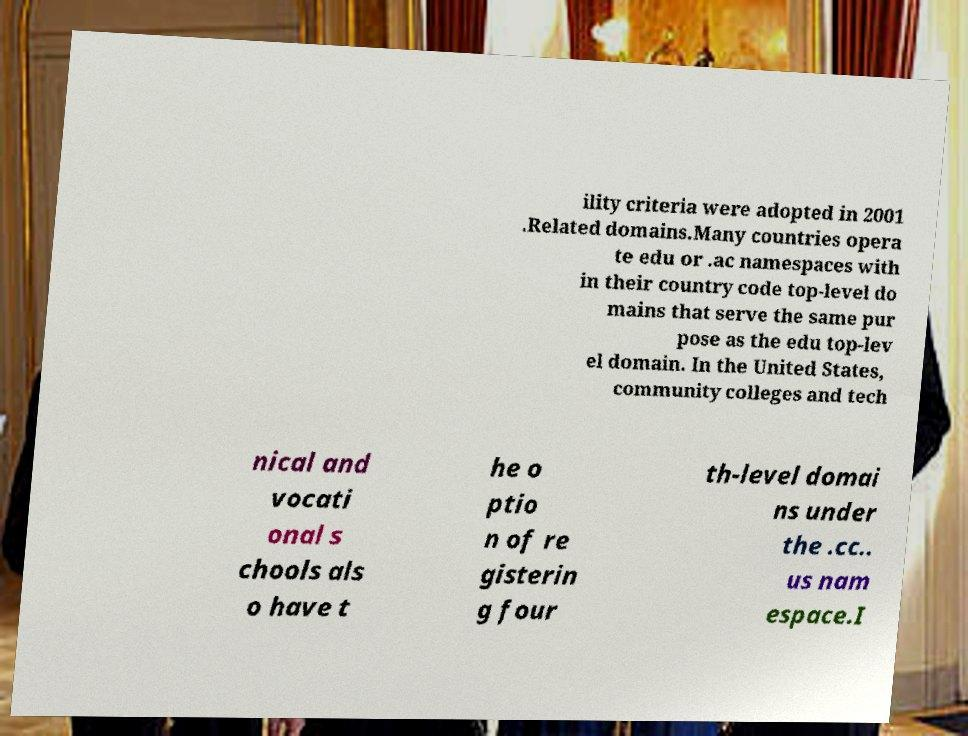For documentation purposes, I need the text within this image transcribed. Could you provide that? ility criteria were adopted in 2001 .Related domains.Many countries opera te edu or .ac namespaces with in their country code top-level do mains that serve the same pur pose as the edu top-lev el domain. In the United States, community colleges and tech nical and vocati onal s chools als o have t he o ptio n of re gisterin g four th-level domai ns under the .cc.. us nam espace.I 